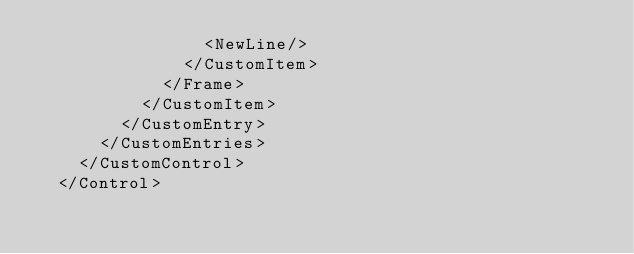<code> <loc_0><loc_0><loc_500><loc_500><_YAML_>                <NewLine/>
              </CustomItem>
            </Frame>
          </CustomItem>
        </CustomEntry>
      </CustomEntries>
    </CustomControl>
  </Control>
</code> 